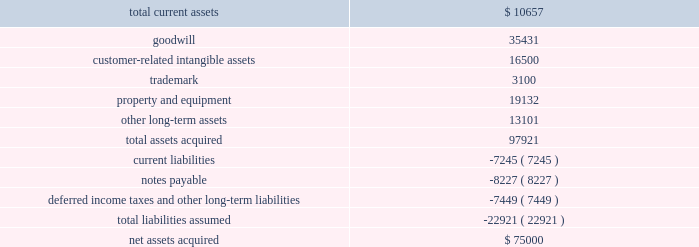Notes to consolidated financial statements 2014 ( continued ) ucs .
As of may 31 , 2009 , $ 55.0 million of the purchase price was held in escrow ( the 201cescrow account 201d ) .
Prior to our acquisition of ucs , the former parent company of ucs pledged the company 2019s stock as collateral for a third party loan ( 201cthe loan 201d ) that matures on september 24 , 2009 .
Upon repayment of this loan , the stock will be released to us and $ 35.0 million of the purchase price will be released to the seller .
The remaining $ 20.0 million will remain in escrow until january 1 , 2013 , to satisfy any liabilities discovered post-closing that existed at the purchase date .
The purpose of this acquisition was to establish an acquiring presence in the russian market and a foundation for other direct acquiring opportunities in central and eastern europe .
The purchase price was determined by analyzing the historical and prospective financial statements and applying relevant purchase price multiples .
This business acquisition was not significant to our consolidated financial statements and accordingly , we have not provided pro forma information relating to this acquisition .
Upon acquisition of ucs global payments assumed an indirect guarantee of the loan .
In the event of a default by the third-party debtor , we would be required to transfer all of the shares of ucs to the trustee or pay the amount outstanding under the loan .
At may 31 , 2009 the maximum potential amount of future payments under the guarantee was $ 44.1 million which represents the total outstanding under the loan , consisting of $ 21.8 million due and paid on june 24 , 2009 and $ 22.3 million due on september 24 , 2009 .
Should the third-party debtor default on the final payment , global payments would pay the total amount outstanding and seek to be reimbursed for any payments made from the $ 55 million held in the escrow account .
We did not record an obligation for this guarantee because we determined that the fair value of the guarantee is de minimis .
The table summarizes the preliminary purchase price allocation ( in thousands ) : .
All of the goodwill associated with the acquisition is non-deductible for tax purposes .
The customer-related intangible assets have amortization periods of 9 to 15 years .
The trademark has an amortization period of 10 years .
Global payments asia-pacific philippines incorporated on september 4 , 2008 , global payments asia-pacific , limited ( 201cgpap 201d ) , the entity through which we conduct our merchant acquiring business in the asia-pacific region , indirectly acquired global payments asia- pacific philippines incorporated ( 201cgpap philippines 201d ) , a newly formed company into which hsbc asia pacific contributed its merchant acquiring business in the philippines .
We own 56% ( 56 % ) of gpap and hsbc asia pacific .
What percentage of total assets acquired was related to goodwill? 
Computations: (35431 / 97921)
Answer: 0.36183. 